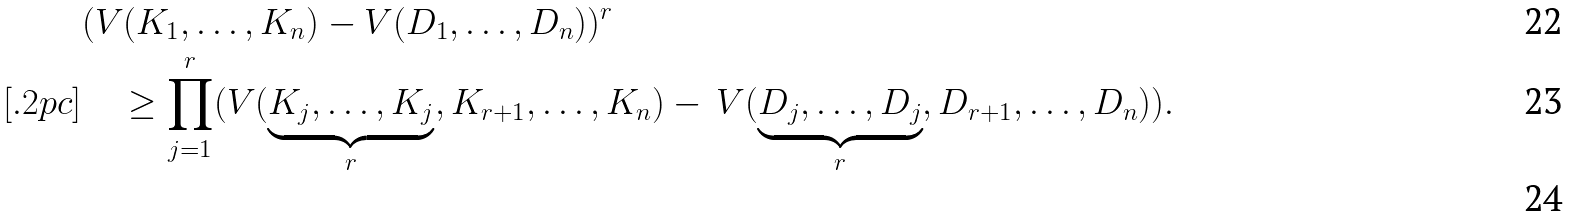Convert formula to latex. <formula><loc_0><loc_0><loc_500><loc_500>& ( V ( K _ { 1 } , \dots , K _ { n } ) - V ( D _ { 1 } , \dots , D _ { n } ) ) ^ { r } \\ [ . 2 p c ] & \quad \geq \prod _ { j = 1 } ^ { r } ( V ( \underbrace { K _ { j } , \dots , K _ { j } } _ { r } , K _ { r + 1 } , \dots , K _ { n } ) - \, V ( \underbrace { D _ { j } , \dots , D _ { j } } _ { r } , D _ { r + 1 } , \dots , D _ { n } ) ) . \\</formula> 